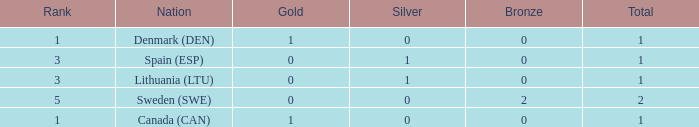Can you give me this table as a dict? {'header': ['Rank', 'Nation', 'Gold', 'Silver', 'Bronze', 'Total'], 'rows': [['1', 'Denmark (DEN)', '1', '0', '0', '1'], ['3', 'Spain (ESP)', '0', '1', '0', '1'], ['3', 'Lithuania (LTU)', '0', '1', '0', '1'], ['5', 'Sweden (SWE)', '0', '0', '2', '2'], ['1', 'Canada (CAN)', '1', '0', '0', '1']]} What is the number of gold medals for Lithuania (ltu), when the total is more than 1? None. 